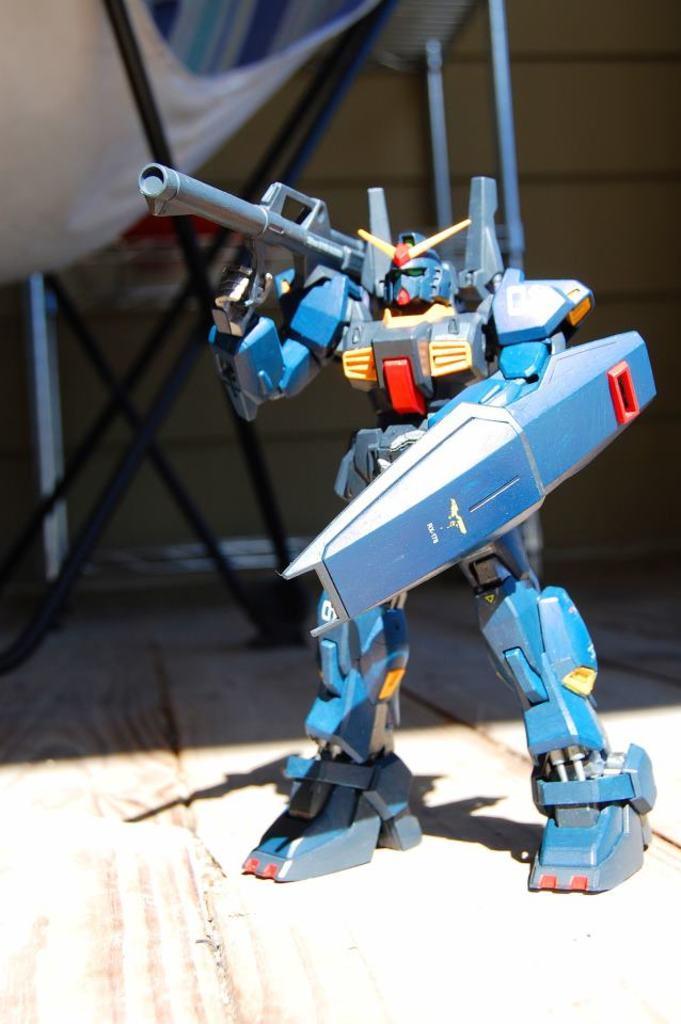How would you summarize this image in a sentence or two? In the center of the image, we can see a robot and in the background, there is a tent. 